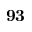<formula> <loc_0><loc_0><loc_500><loc_500>9 3</formula> 